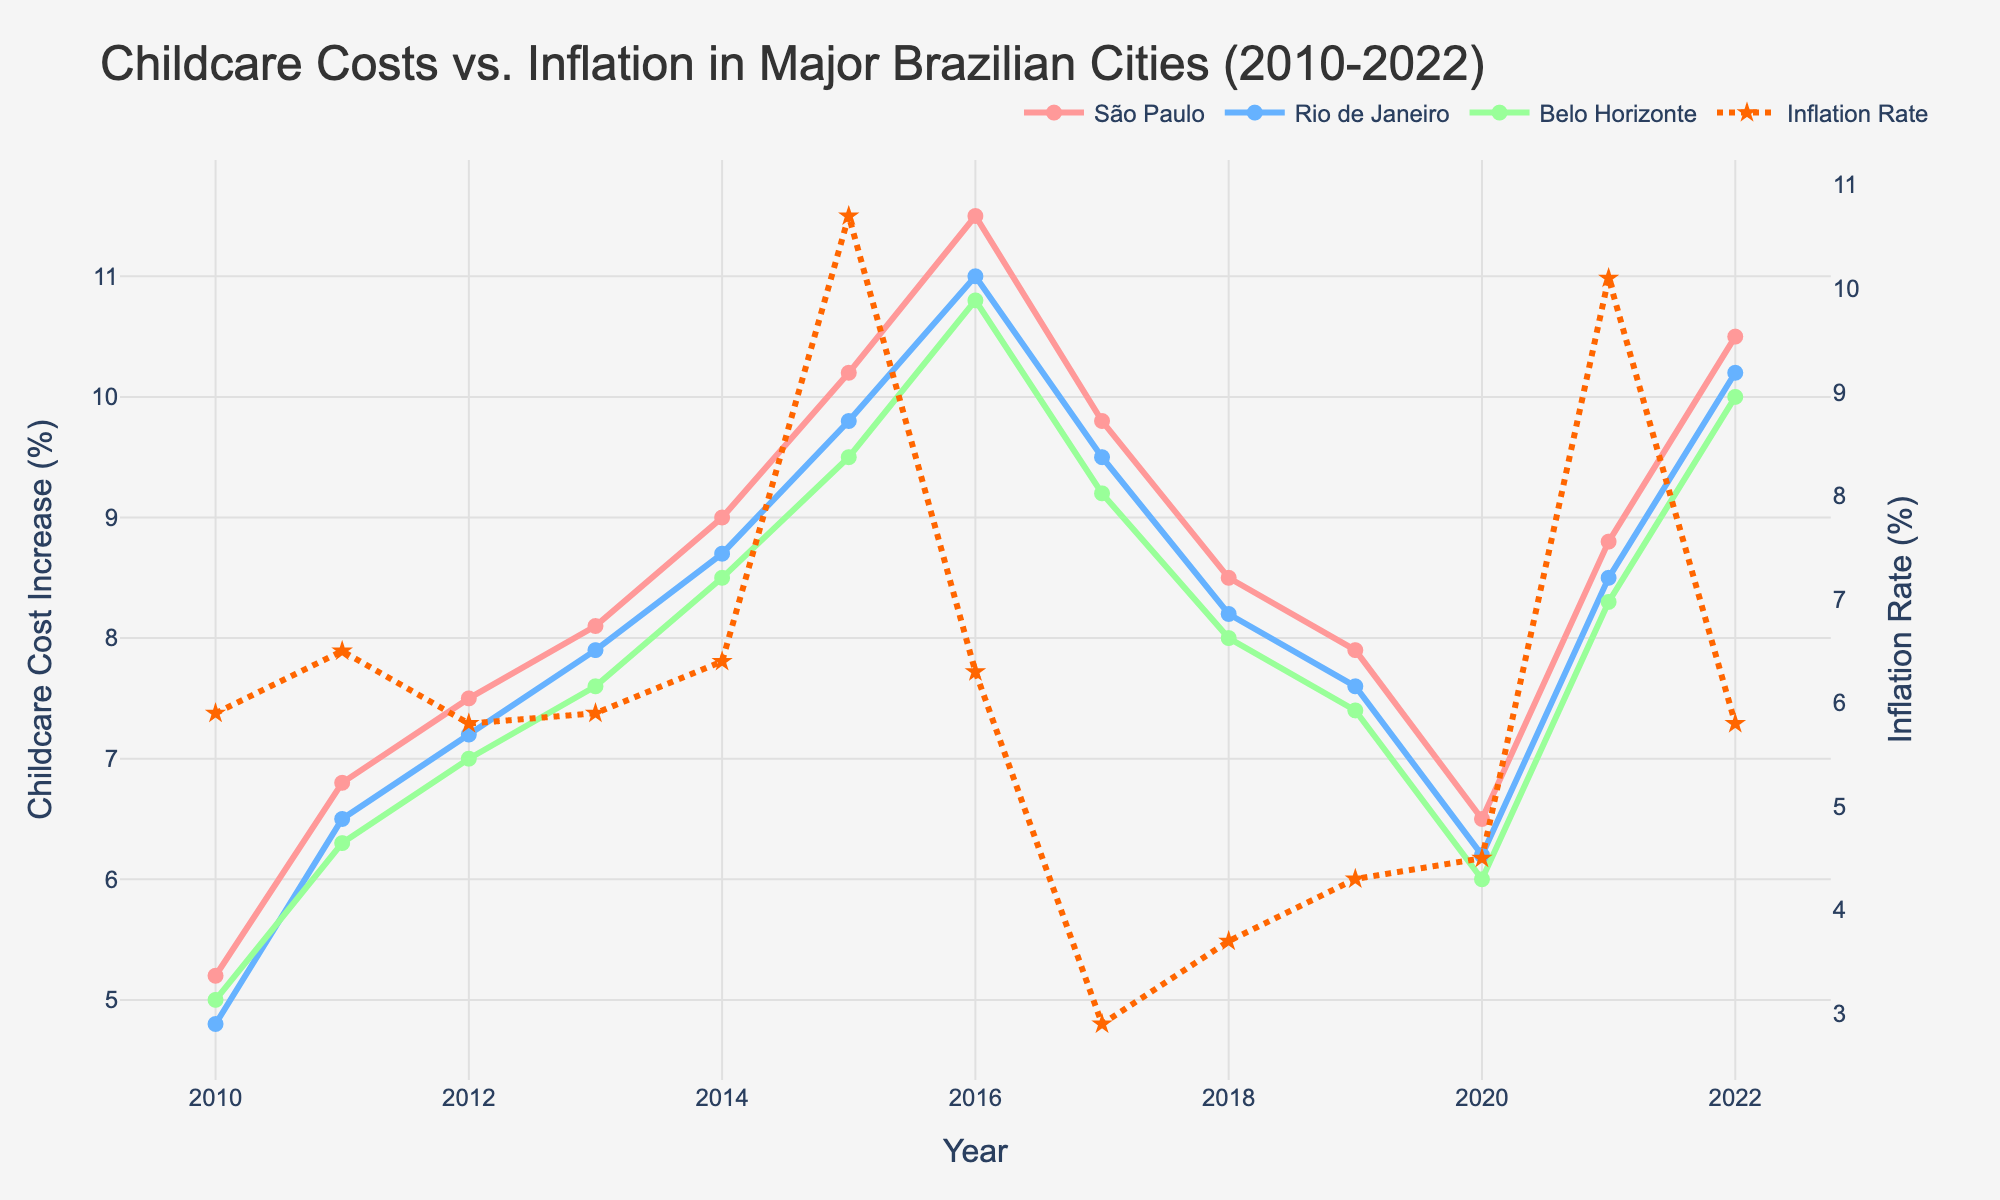What's the average increase in childcare costs for São Paulo between 2015 and 2020? To find the average increase, sum the values from 2015 to 2020 and divide by the number of years. São Paulo increases are 10.2, 11.5, 9.8, 8.5, 7.9, and 6.5. Sum = 54.4 and there are 6 years. Average = 54.4 / 6.
Answer: 9.07 Which city had the highest childcare cost increase in 2022? Compare the 2022 childcare costs for São Paulo (10.5%), Rio de Janeiro (10.2%), and Belo Horizonte (10.0%). São Paulo has the highest value.
Answer: São Paulo Did the childcare cost in São Paulo ever surpass the inflation rate? Compare the yearly data of São Paulo childcare costs and the inflation rate. In 2016, São Paulo's rate was 11.5% while inflation was 6.3%. Similarly in 2022, São Paulo had 10.5% and inflation was 5.8%.
Answer: Yes What was the difference between the inflation rate and São Paulo's childcare cost increase in 2015? Subtract the inflation rate in 2015 (10.7%) from São Paulo's childcare cost increase (10.2%). Difference = 10.2 - 10.7 = -0.5%.
Answer: -0.5% In which year did Rio de Janeiro have its lowest childcare cost increase? Review all years, Rio de Janeiro's lowest increase is in 2010 with a rate of 4.8%.
Answer: 2010 What was the trend in the inflation rate from 2016 to 2017? Check the inflation rate from 2016 (6.3%) and compare it to 2017 (2.9%). The rate decreased.
Answer: Decreasing How does the cost increase in childcare in Belo Horizonte in 2020 compare to inflation in the same year? In 2020, compare Belo Horizonte's cost increase (6.0%) to inflation (4.5%). Belo Horizonte's increase is higher.
Answer: Higher Which city had the smallest differential between childcare cost increase and inflation in 2011? Compare all cities: São Paulo (6.8% - 6.5% = 0.3%), Rio de Janeiro (6.5% - 6.5% = 0%), Belo Horizonte (6.3% - 6.5% = -0.2%). Rio de Janeiro had the smallest differential.
Answer: Rio de Janeiro What was the overall range of childcare cost increases for São Paulo from 2010 to 2022? Find the maximum and minimum values from São Paulo's data. The maximum increase is 11.5% (2016), and the minimum is 5.2% (2010). The range is 11.5% - 5.2% = 6.3%.
Answer: 6.3% Which data point represents the highest discrepancy between childcare cost increases and inflation rate across all years and cities? Calculate differences for all data points. The highest discrepancy is in 2016 with São Paulo. Childcare cost increase is 11.5% and inflation rate is 6.3%. Discrepancy = 11.5% - 6.3% = 5.2%.
Answer: São Paulo in 2016 